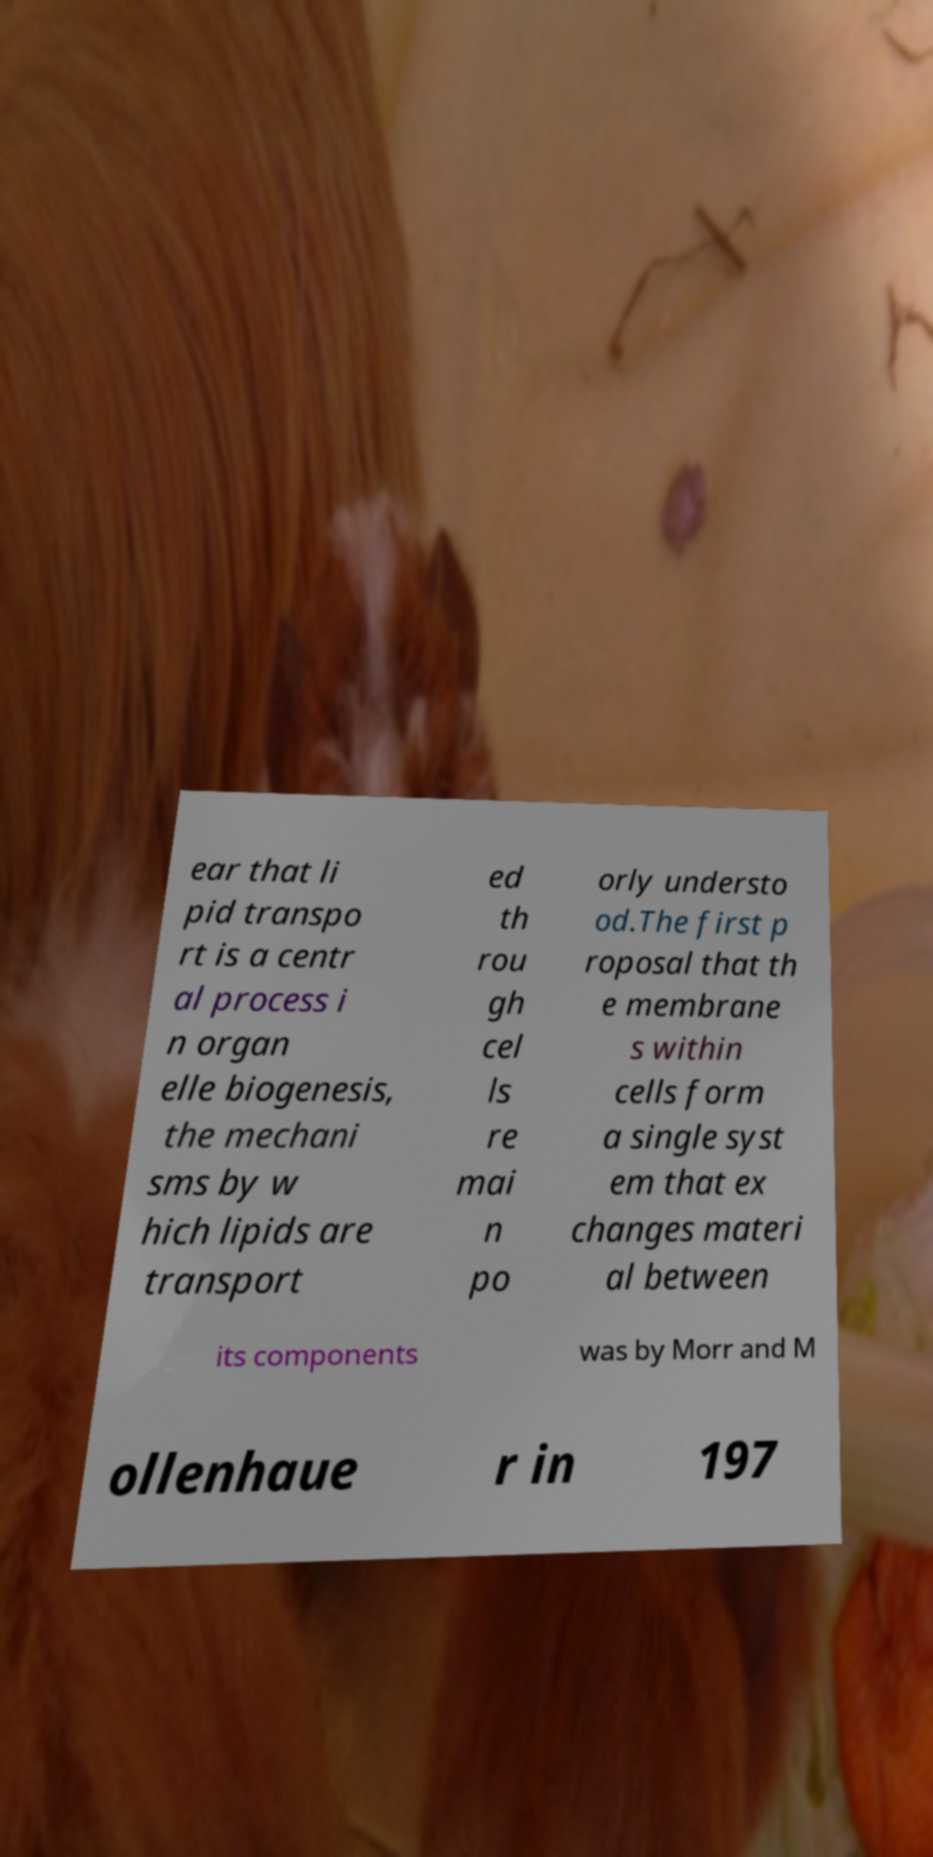What messages or text are displayed in this image? I need them in a readable, typed format. ear that li pid transpo rt is a centr al process i n organ elle biogenesis, the mechani sms by w hich lipids are transport ed th rou gh cel ls re mai n po orly understo od.The first p roposal that th e membrane s within cells form a single syst em that ex changes materi al between its components was by Morr and M ollenhaue r in 197 